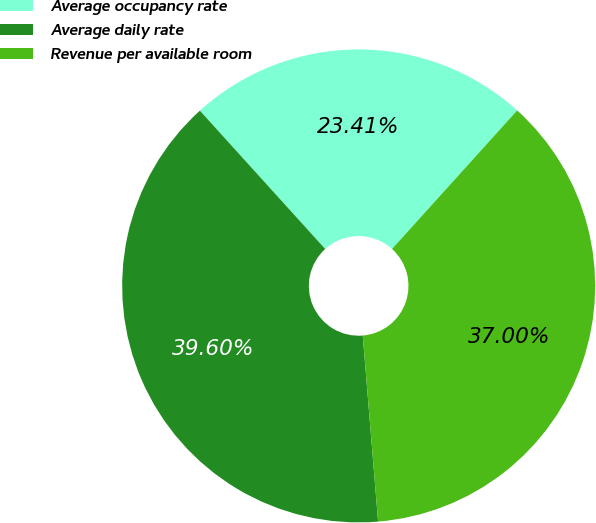Convert chart to OTSL. <chart><loc_0><loc_0><loc_500><loc_500><pie_chart><fcel>Average occupancy rate<fcel>Average daily rate<fcel>Revenue per available room<nl><fcel>23.41%<fcel>39.6%<fcel>37.0%<nl></chart> 